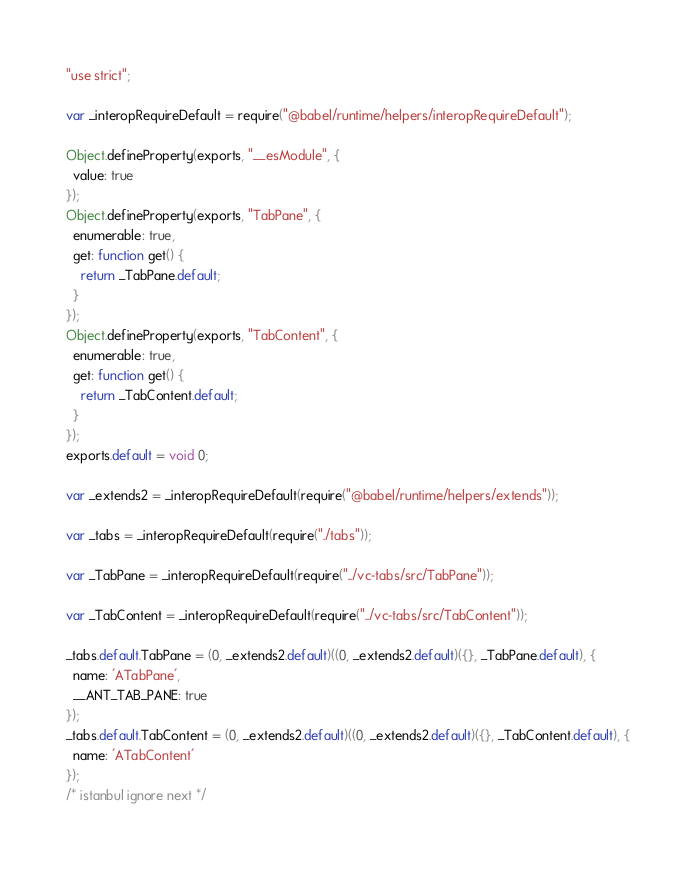Convert code to text. <code><loc_0><loc_0><loc_500><loc_500><_JavaScript_>"use strict";

var _interopRequireDefault = require("@babel/runtime/helpers/interopRequireDefault");

Object.defineProperty(exports, "__esModule", {
  value: true
});
Object.defineProperty(exports, "TabPane", {
  enumerable: true,
  get: function get() {
    return _TabPane.default;
  }
});
Object.defineProperty(exports, "TabContent", {
  enumerable: true,
  get: function get() {
    return _TabContent.default;
  }
});
exports.default = void 0;

var _extends2 = _interopRequireDefault(require("@babel/runtime/helpers/extends"));

var _tabs = _interopRequireDefault(require("./tabs"));

var _TabPane = _interopRequireDefault(require("../vc-tabs/src/TabPane"));

var _TabContent = _interopRequireDefault(require("../vc-tabs/src/TabContent"));

_tabs.default.TabPane = (0, _extends2.default)((0, _extends2.default)({}, _TabPane.default), {
  name: 'ATabPane',
  __ANT_TAB_PANE: true
});
_tabs.default.TabContent = (0, _extends2.default)((0, _extends2.default)({}, _TabContent.default), {
  name: 'ATabContent'
});
/* istanbul ignore next */
</code> 